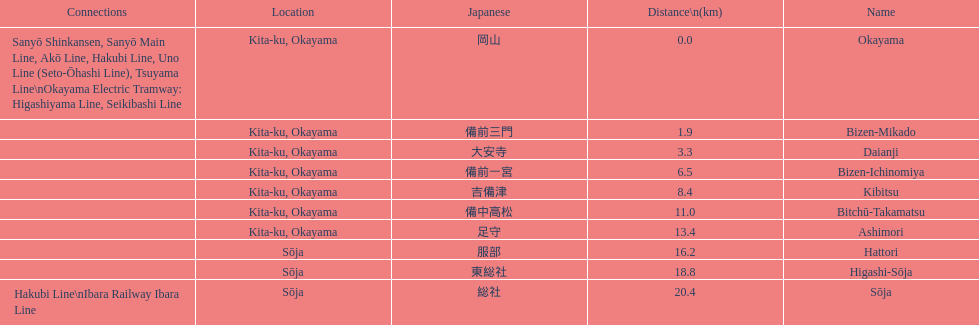How many consecutive stops must you travel through is you board the kibi line at bizen-mikado at depart at kibitsu? 2. 